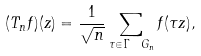Convert formula to latex. <formula><loc_0><loc_0><loc_500><loc_500>( T _ { n } f ) ( z ) = \frac { 1 } { \sqrt { n } } \sum _ { \tau \in \Gamma \ G _ { n } } f ( \tau z ) ,</formula> 